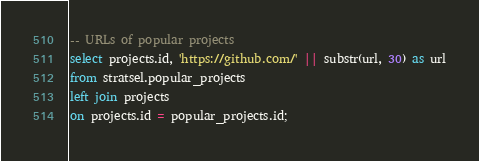Convert code to text. <code><loc_0><loc_0><loc_500><loc_500><_SQL_>-- URLs of popular projects
select projects.id, 'https://github.com/' || substr(url, 30) as url
from stratsel.popular_projects
left join projects
on projects.id = popular_projects.id;
</code> 